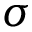<formula> <loc_0><loc_0><loc_500><loc_500>\sigma</formula> 